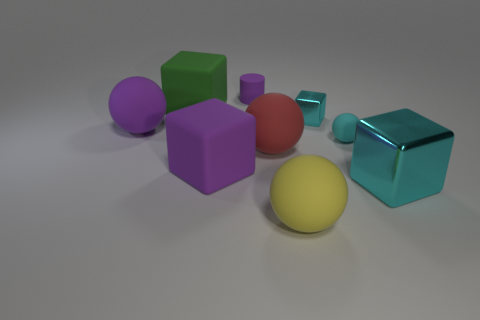Can you describe the size relations between different objects? Certainly. There are objects of various sizes, with the smaller spheres and cylinders contrasted against the noticeably larger cubes. The size comparison emphasizes diversity in spatial dimensions among the elements. 